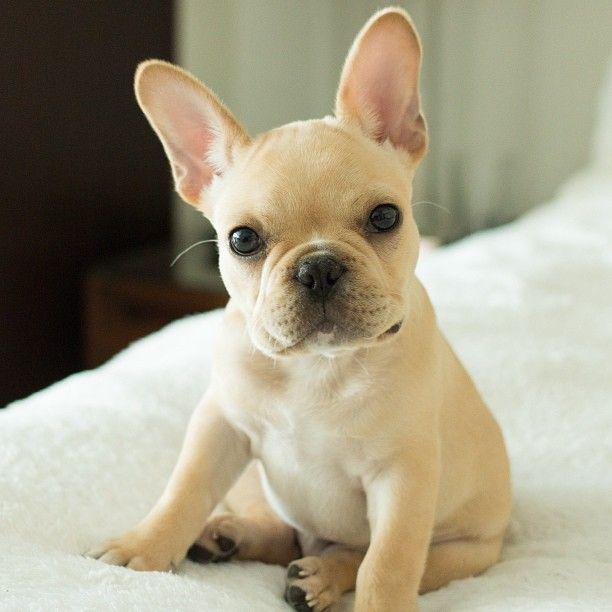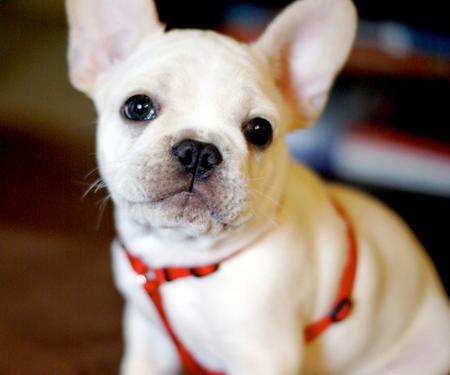The first image is the image on the left, the second image is the image on the right. For the images shown, is this caption "The dog is resting on a bed or couch and is photographed alone." true? Answer yes or no. Yes. 